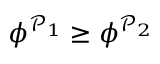Convert formula to latex. <formula><loc_0><loc_0><loc_500><loc_500>\phi ^ { \mathcal { P } _ { 1 } } \geq \phi ^ { \mathcal { P } _ { 2 } }</formula> 